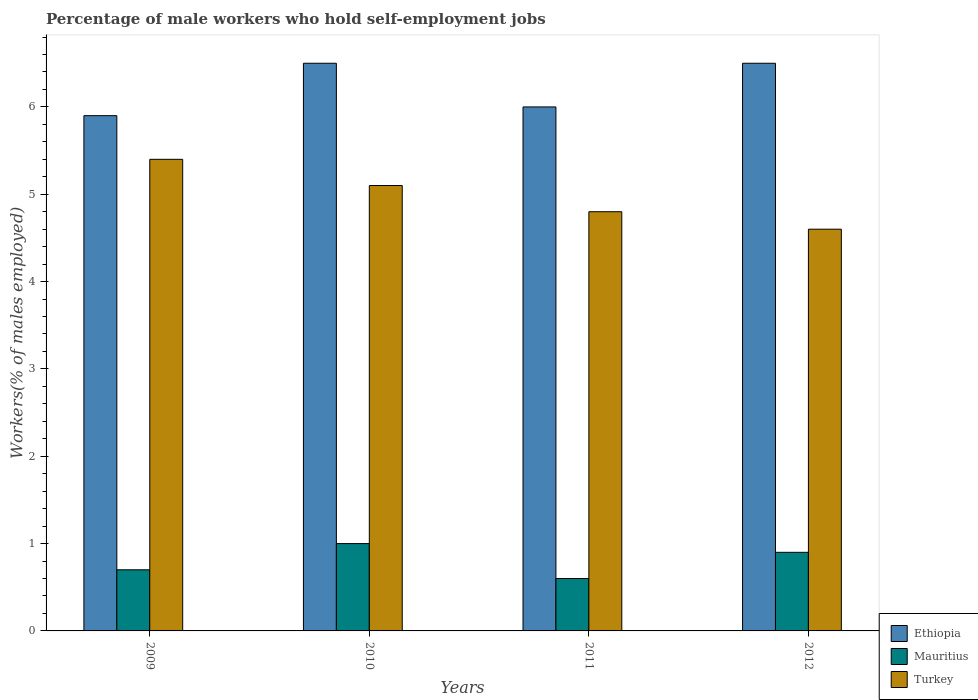How many different coloured bars are there?
Keep it short and to the point. 3. Are the number of bars per tick equal to the number of legend labels?
Your answer should be very brief. Yes. Are the number of bars on each tick of the X-axis equal?
Offer a terse response. Yes. How many bars are there on the 1st tick from the right?
Keep it short and to the point. 3. What is the percentage of self-employed male workers in Mauritius in 2012?
Your answer should be very brief. 0.9. Across all years, what is the maximum percentage of self-employed male workers in Mauritius?
Make the answer very short. 1. Across all years, what is the minimum percentage of self-employed male workers in Turkey?
Provide a succinct answer. 4.6. What is the total percentage of self-employed male workers in Mauritius in the graph?
Your response must be concise. 3.2. What is the difference between the percentage of self-employed male workers in Mauritius in 2009 and the percentage of self-employed male workers in Ethiopia in 2012?
Offer a terse response. -5.8. What is the average percentage of self-employed male workers in Turkey per year?
Make the answer very short. 4.98. In the year 2009, what is the difference between the percentage of self-employed male workers in Mauritius and percentage of self-employed male workers in Ethiopia?
Keep it short and to the point. -5.2. What is the ratio of the percentage of self-employed male workers in Turkey in 2011 to that in 2012?
Keep it short and to the point. 1.04. Is the percentage of self-employed male workers in Mauritius in 2009 less than that in 2011?
Provide a short and direct response. No. Is the difference between the percentage of self-employed male workers in Mauritius in 2010 and 2011 greater than the difference between the percentage of self-employed male workers in Ethiopia in 2010 and 2011?
Make the answer very short. No. What is the difference between the highest and the lowest percentage of self-employed male workers in Ethiopia?
Your answer should be very brief. 0.6. In how many years, is the percentage of self-employed male workers in Mauritius greater than the average percentage of self-employed male workers in Mauritius taken over all years?
Keep it short and to the point. 2. What does the 3rd bar from the right in 2012 represents?
Give a very brief answer. Ethiopia. Is it the case that in every year, the sum of the percentage of self-employed male workers in Turkey and percentage of self-employed male workers in Ethiopia is greater than the percentage of self-employed male workers in Mauritius?
Your answer should be very brief. Yes. How many years are there in the graph?
Provide a succinct answer. 4. What is the difference between two consecutive major ticks on the Y-axis?
Provide a short and direct response. 1. Does the graph contain any zero values?
Provide a short and direct response. No. What is the title of the graph?
Provide a succinct answer. Percentage of male workers who hold self-employment jobs. Does "Burundi" appear as one of the legend labels in the graph?
Provide a short and direct response. No. What is the label or title of the Y-axis?
Ensure brevity in your answer.  Workers(% of males employed). What is the Workers(% of males employed) in Ethiopia in 2009?
Keep it short and to the point. 5.9. What is the Workers(% of males employed) of Mauritius in 2009?
Provide a succinct answer. 0.7. What is the Workers(% of males employed) in Turkey in 2009?
Keep it short and to the point. 5.4. What is the Workers(% of males employed) in Ethiopia in 2010?
Your answer should be compact. 6.5. What is the Workers(% of males employed) in Mauritius in 2010?
Ensure brevity in your answer.  1. What is the Workers(% of males employed) in Turkey in 2010?
Make the answer very short. 5.1. What is the Workers(% of males employed) of Mauritius in 2011?
Give a very brief answer. 0.6. What is the Workers(% of males employed) in Turkey in 2011?
Offer a terse response. 4.8. What is the Workers(% of males employed) in Mauritius in 2012?
Make the answer very short. 0.9. What is the Workers(% of males employed) in Turkey in 2012?
Your answer should be compact. 4.6. Across all years, what is the maximum Workers(% of males employed) in Mauritius?
Provide a succinct answer. 1. Across all years, what is the maximum Workers(% of males employed) in Turkey?
Provide a succinct answer. 5.4. Across all years, what is the minimum Workers(% of males employed) in Ethiopia?
Your answer should be compact. 5.9. Across all years, what is the minimum Workers(% of males employed) in Mauritius?
Make the answer very short. 0.6. Across all years, what is the minimum Workers(% of males employed) of Turkey?
Offer a terse response. 4.6. What is the total Workers(% of males employed) in Ethiopia in the graph?
Offer a very short reply. 24.9. What is the total Workers(% of males employed) in Turkey in the graph?
Provide a short and direct response. 19.9. What is the difference between the Workers(% of males employed) of Mauritius in 2009 and that in 2011?
Provide a short and direct response. 0.1. What is the difference between the Workers(% of males employed) in Ethiopia in 2009 and that in 2012?
Offer a terse response. -0.6. What is the difference between the Workers(% of males employed) of Mauritius in 2009 and that in 2012?
Provide a succinct answer. -0.2. What is the difference between the Workers(% of males employed) of Turkey in 2009 and that in 2012?
Your answer should be very brief. 0.8. What is the difference between the Workers(% of males employed) of Mauritius in 2010 and that in 2011?
Make the answer very short. 0.4. What is the difference between the Workers(% of males employed) in Mauritius in 2010 and that in 2012?
Provide a short and direct response. 0.1. What is the difference between the Workers(% of males employed) in Ethiopia in 2011 and that in 2012?
Ensure brevity in your answer.  -0.5. What is the difference between the Workers(% of males employed) of Ethiopia in 2009 and the Workers(% of males employed) of Mauritius in 2010?
Provide a succinct answer. 4.9. What is the difference between the Workers(% of males employed) of Ethiopia in 2009 and the Workers(% of males employed) of Turkey in 2010?
Your answer should be very brief. 0.8. What is the difference between the Workers(% of males employed) in Mauritius in 2009 and the Workers(% of males employed) in Turkey in 2010?
Make the answer very short. -4.4. What is the difference between the Workers(% of males employed) of Ethiopia in 2009 and the Workers(% of males employed) of Mauritius in 2011?
Your answer should be compact. 5.3. What is the difference between the Workers(% of males employed) of Mauritius in 2009 and the Workers(% of males employed) of Turkey in 2012?
Offer a terse response. -3.9. What is the difference between the Workers(% of males employed) in Ethiopia in 2010 and the Workers(% of males employed) in Turkey in 2011?
Offer a very short reply. 1.7. What is the difference between the Workers(% of males employed) of Mauritius in 2010 and the Workers(% of males employed) of Turkey in 2011?
Offer a very short reply. -3.8. What is the difference between the Workers(% of males employed) in Ethiopia in 2010 and the Workers(% of males employed) in Turkey in 2012?
Offer a terse response. 1.9. What is the difference between the Workers(% of males employed) in Mauritius in 2010 and the Workers(% of males employed) in Turkey in 2012?
Provide a short and direct response. -3.6. What is the difference between the Workers(% of males employed) of Ethiopia in 2011 and the Workers(% of males employed) of Mauritius in 2012?
Your answer should be very brief. 5.1. What is the difference between the Workers(% of males employed) of Ethiopia in 2011 and the Workers(% of males employed) of Turkey in 2012?
Ensure brevity in your answer.  1.4. What is the difference between the Workers(% of males employed) of Mauritius in 2011 and the Workers(% of males employed) of Turkey in 2012?
Your response must be concise. -4. What is the average Workers(% of males employed) in Ethiopia per year?
Offer a terse response. 6.22. What is the average Workers(% of males employed) of Mauritius per year?
Make the answer very short. 0.8. What is the average Workers(% of males employed) in Turkey per year?
Provide a succinct answer. 4.97. In the year 2010, what is the difference between the Workers(% of males employed) of Ethiopia and Workers(% of males employed) of Mauritius?
Your answer should be very brief. 5.5. In the year 2010, what is the difference between the Workers(% of males employed) of Mauritius and Workers(% of males employed) of Turkey?
Offer a very short reply. -4.1. In the year 2011, what is the difference between the Workers(% of males employed) of Ethiopia and Workers(% of males employed) of Turkey?
Offer a terse response. 1.2. In the year 2011, what is the difference between the Workers(% of males employed) in Mauritius and Workers(% of males employed) in Turkey?
Provide a succinct answer. -4.2. In the year 2012, what is the difference between the Workers(% of males employed) in Mauritius and Workers(% of males employed) in Turkey?
Offer a terse response. -3.7. What is the ratio of the Workers(% of males employed) in Ethiopia in 2009 to that in 2010?
Ensure brevity in your answer.  0.91. What is the ratio of the Workers(% of males employed) in Mauritius in 2009 to that in 2010?
Provide a short and direct response. 0.7. What is the ratio of the Workers(% of males employed) in Turkey in 2009 to that in 2010?
Your answer should be very brief. 1.06. What is the ratio of the Workers(% of males employed) of Ethiopia in 2009 to that in 2011?
Provide a short and direct response. 0.98. What is the ratio of the Workers(% of males employed) in Mauritius in 2009 to that in 2011?
Keep it short and to the point. 1.17. What is the ratio of the Workers(% of males employed) in Ethiopia in 2009 to that in 2012?
Provide a short and direct response. 0.91. What is the ratio of the Workers(% of males employed) of Mauritius in 2009 to that in 2012?
Offer a terse response. 0.78. What is the ratio of the Workers(% of males employed) of Turkey in 2009 to that in 2012?
Ensure brevity in your answer.  1.17. What is the ratio of the Workers(% of males employed) of Mauritius in 2010 to that in 2011?
Ensure brevity in your answer.  1.67. What is the ratio of the Workers(% of males employed) in Turkey in 2010 to that in 2011?
Keep it short and to the point. 1.06. What is the ratio of the Workers(% of males employed) of Ethiopia in 2010 to that in 2012?
Your response must be concise. 1. What is the ratio of the Workers(% of males employed) in Turkey in 2010 to that in 2012?
Provide a succinct answer. 1.11. What is the ratio of the Workers(% of males employed) of Turkey in 2011 to that in 2012?
Give a very brief answer. 1.04. What is the difference between the highest and the second highest Workers(% of males employed) in Ethiopia?
Give a very brief answer. 0. 